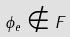Convert formula to latex. <formula><loc_0><loc_0><loc_500><loc_500>\phi _ { e } \notin F</formula> 